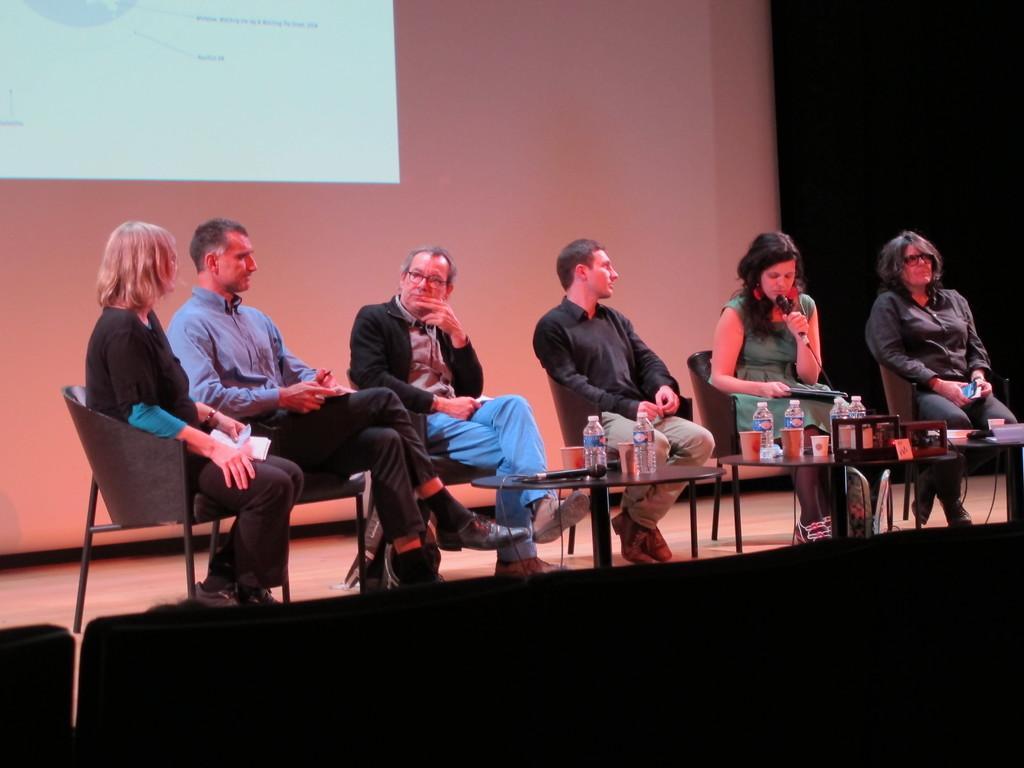Could you give a brief overview of what you see in this image? On the background we can see a wall and a screen over it. Here we can see few persons sitting on chairs in front of a table. This woman is holding a mike in her hand and on the table we can see see a nike, water bottles, cups. 